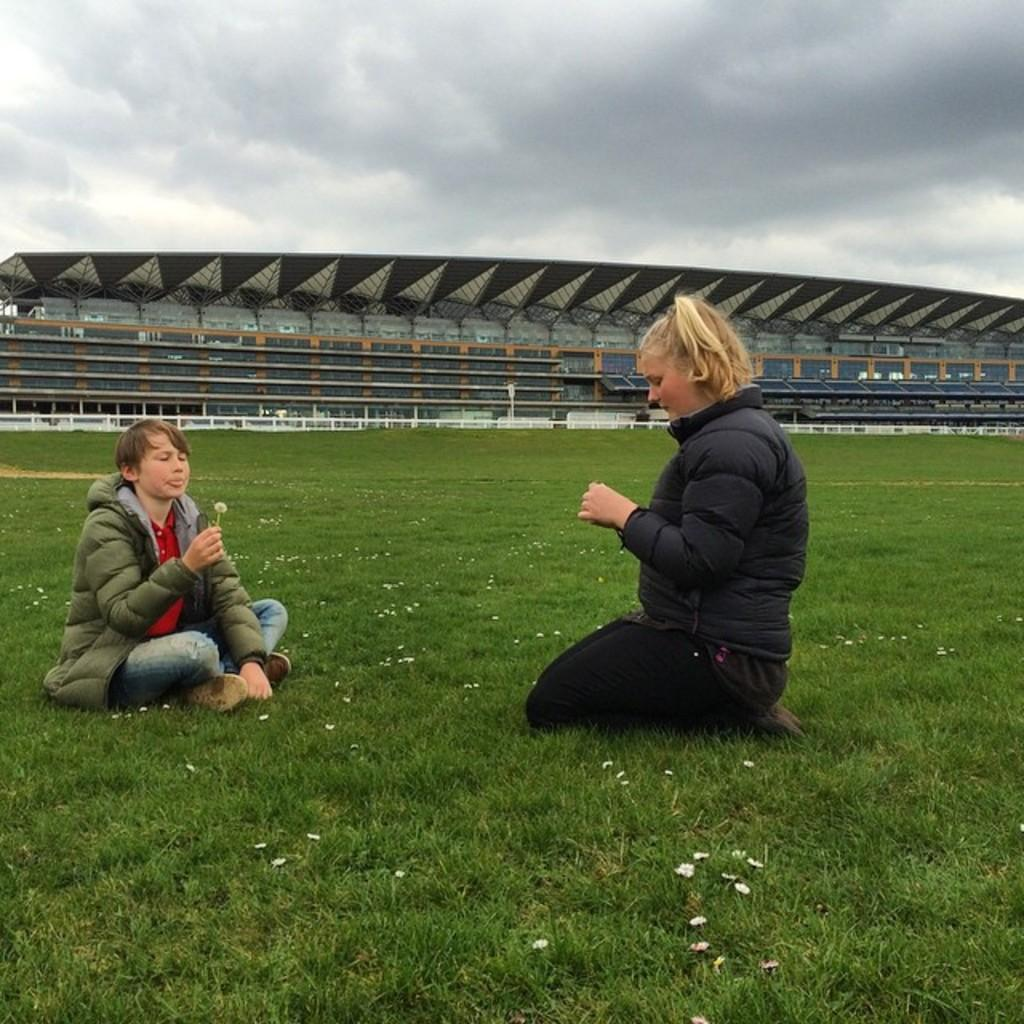How many people are in the image? There are two people in the image. What are the people doing in the image? The people are sitting on the grass and holding flowers in their hands. What else can be seen around the people? There are flowers around the people. What can be seen in the background of the image? There is a stadium visible in the image. What type of hour can be seen on the people's wrists in the image? There are no watches or any indication of time in the image, so it is not possible to determine the type of hour. 